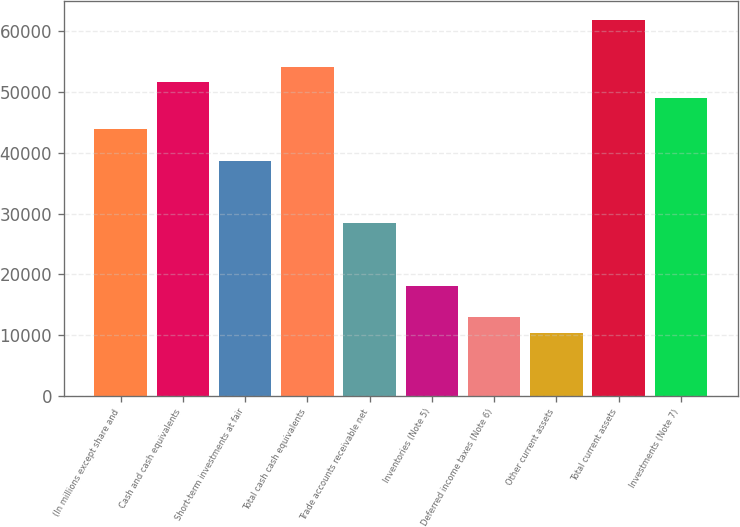<chart> <loc_0><loc_0><loc_500><loc_500><bar_chart><fcel>(In millions except share and<fcel>Cash and cash equivalents<fcel>Short-term investments at fair<fcel>Total cash cash equivalents<fcel>Trade accounts receivable net<fcel>Inventories (Note 5)<fcel>Deferred income taxes (Note 6)<fcel>Other current assets<fcel>Total current assets<fcel>Investments (Note 7)<nl><fcel>43886<fcel>51623<fcel>38728<fcel>54202<fcel>28412<fcel>18096<fcel>12938<fcel>10359<fcel>61939<fcel>49044<nl></chart> 